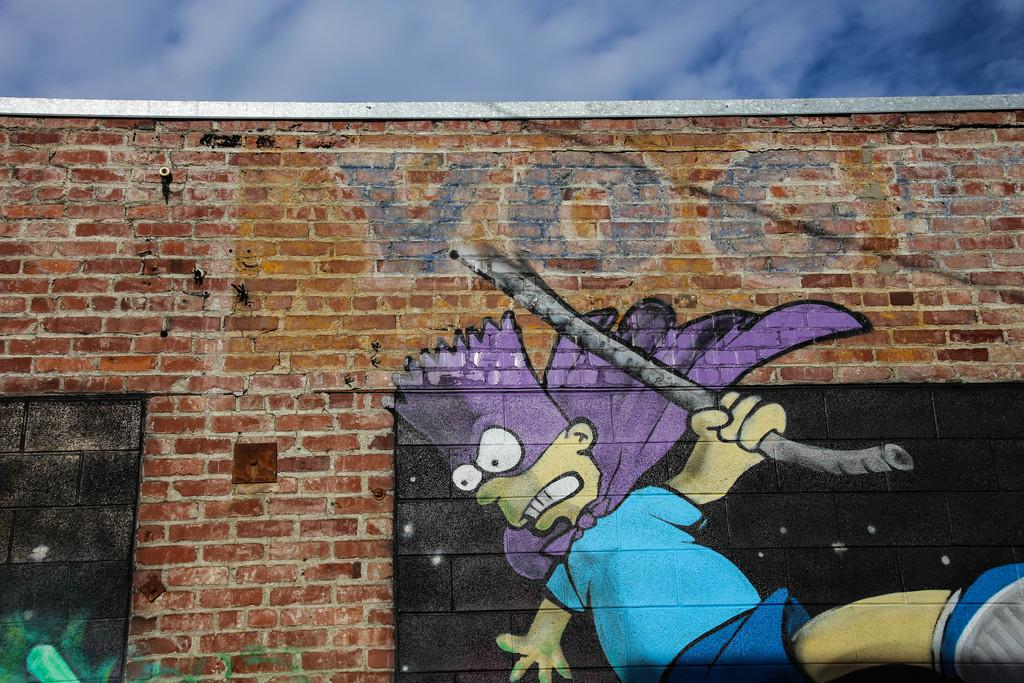What type of artwork is on the wall in the image? There is a painting of a cartoon image on the wall. What material is the wall made of? The wall is built with bricks. What can be seen at the top of the image? The sky is visible at the top of the image. What is the price of the bed in the image? There is no bed present in the image, so it is not possible to determine its price. 